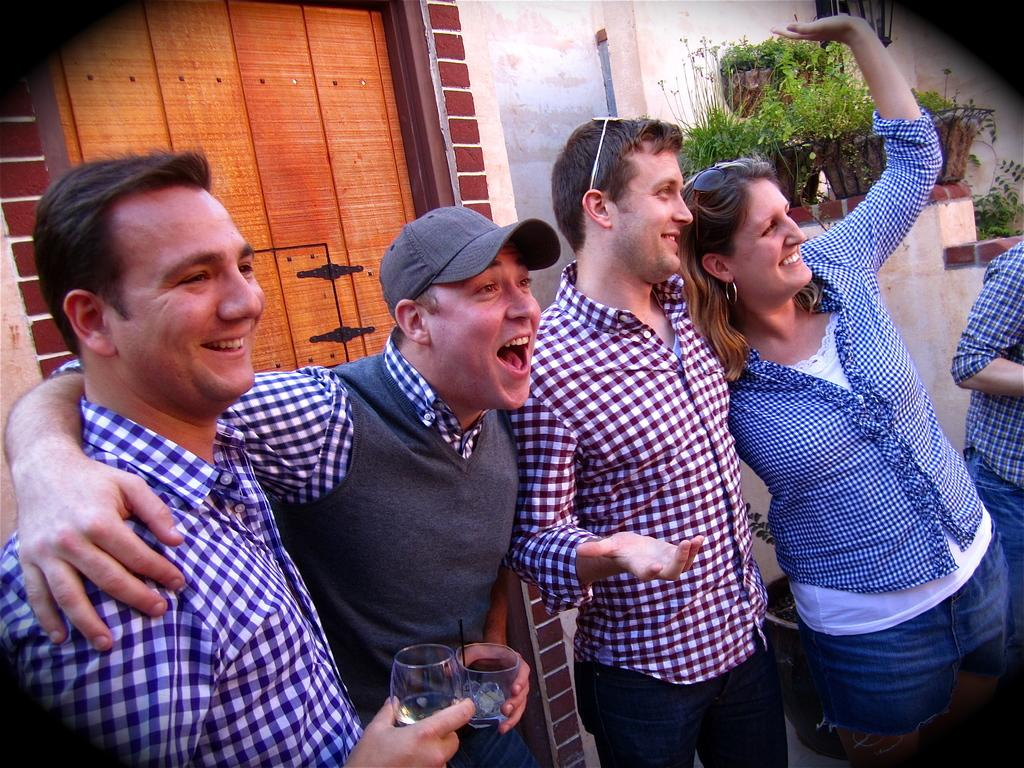What are the people in the image doing? There are people standing in the image. What are two of the people holding in their hands? Two of the people are holding glasses in their hands. What can be seen in the distance behind the people? There are buildings visible in the background of the image. What type of objects are present in the image that might be used for decoration or gardening? There are plant pots in the image. How does the connection between the people and the shop in the image affect their behavior? There is no shop present in the image, and therefore no connection between the people and a shop can be observed. 